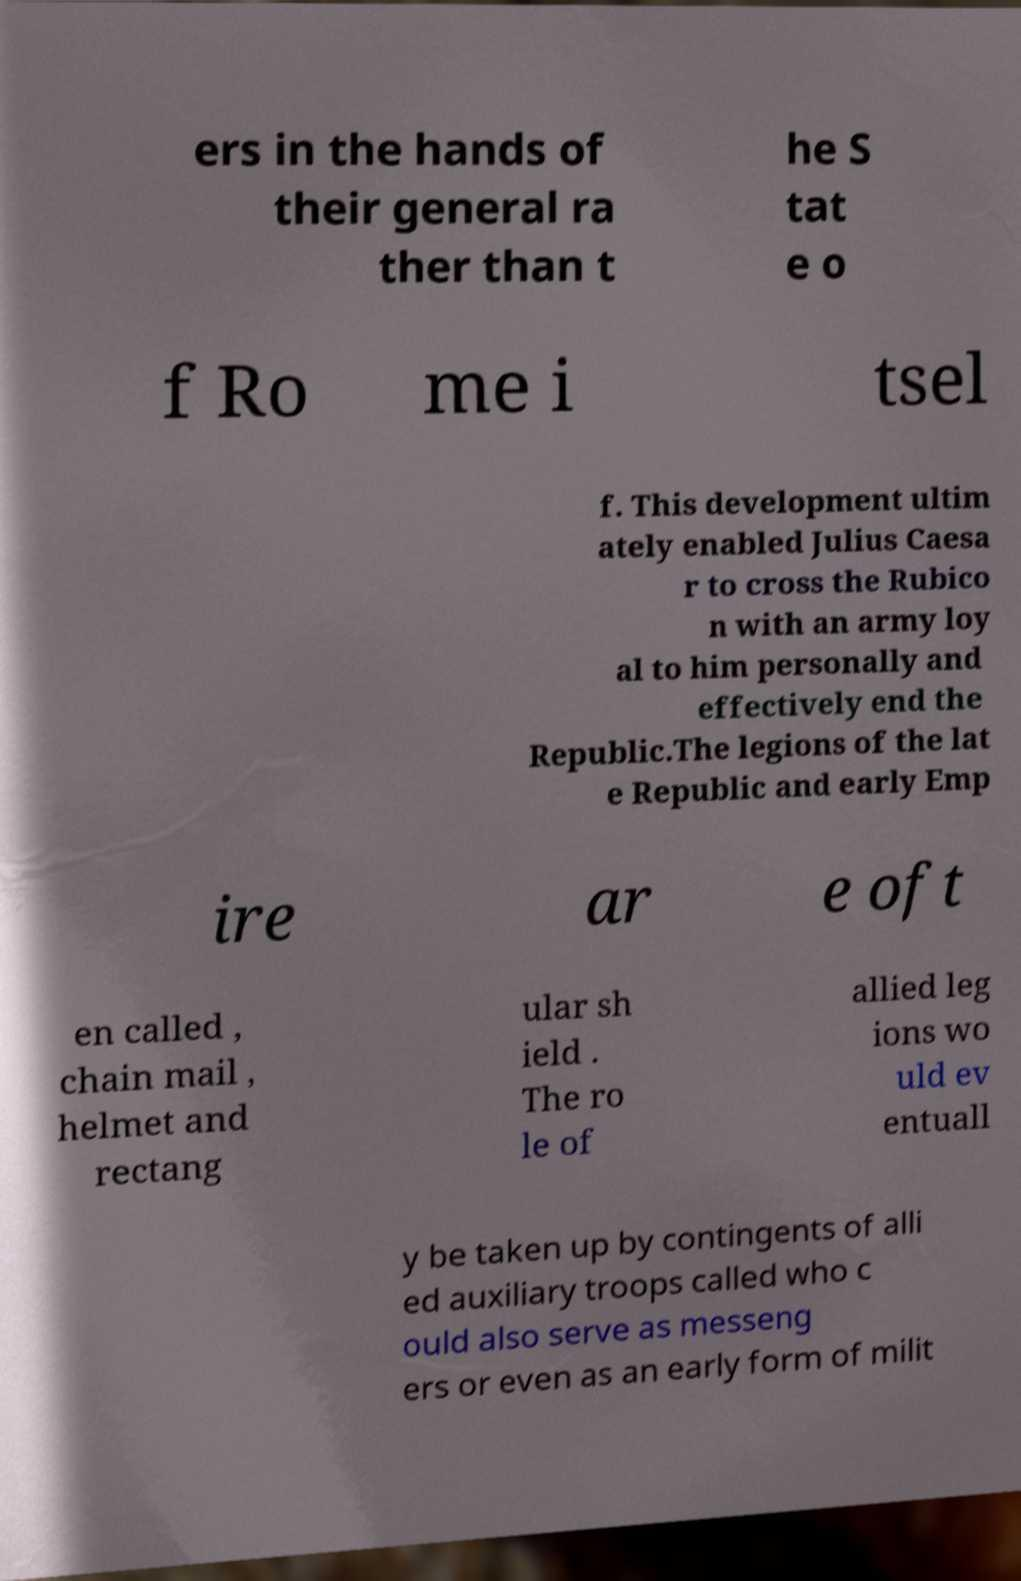There's text embedded in this image that I need extracted. Can you transcribe it verbatim? ers in the hands of their general ra ther than t he S tat e o f Ro me i tsel f. This development ultim ately enabled Julius Caesa r to cross the Rubico n with an army loy al to him personally and effectively end the Republic.The legions of the lat e Republic and early Emp ire ar e oft en called , chain mail , helmet and rectang ular sh ield . The ro le of allied leg ions wo uld ev entuall y be taken up by contingents of alli ed auxiliary troops called who c ould also serve as messeng ers or even as an early form of milit 